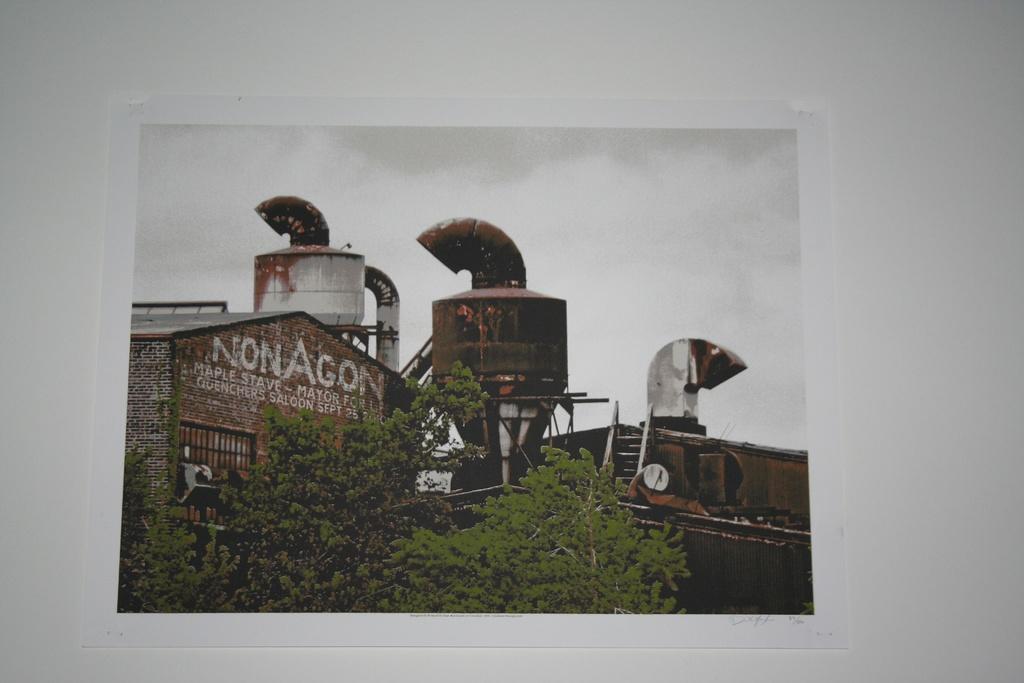What month is mentioned on the building?
Provide a short and direct response. September. Whats word can be seen on in big white letters on the building?
Provide a short and direct response. Nonagon. 